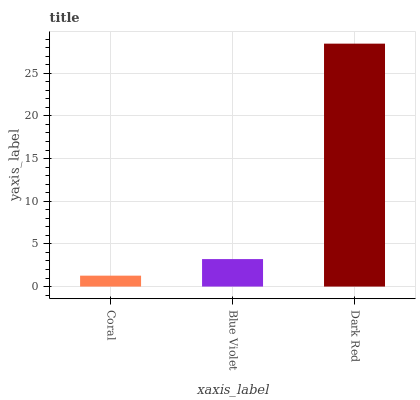Is Coral the minimum?
Answer yes or no. Yes. Is Dark Red the maximum?
Answer yes or no. Yes. Is Blue Violet the minimum?
Answer yes or no. No. Is Blue Violet the maximum?
Answer yes or no. No. Is Blue Violet greater than Coral?
Answer yes or no. Yes. Is Coral less than Blue Violet?
Answer yes or no. Yes. Is Coral greater than Blue Violet?
Answer yes or no. No. Is Blue Violet less than Coral?
Answer yes or no. No. Is Blue Violet the high median?
Answer yes or no. Yes. Is Blue Violet the low median?
Answer yes or no. Yes. Is Dark Red the high median?
Answer yes or no. No. Is Coral the low median?
Answer yes or no. No. 